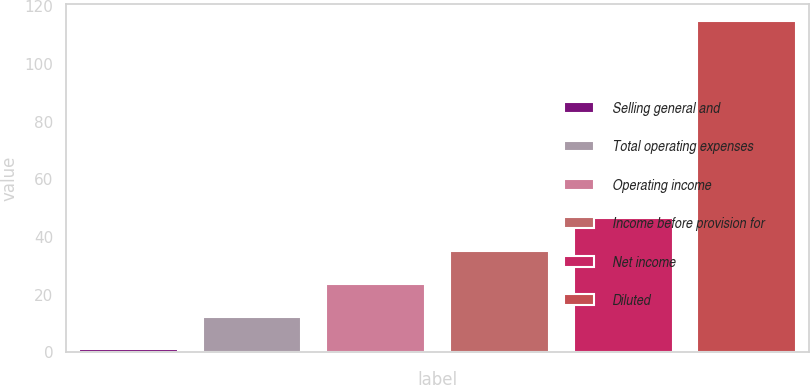Convert chart. <chart><loc_0><loc_0><loc_500><loc_500><bar_chart><fcel>Selling general and<fcel>Total operating expenses<fcel>Operating income<fcel>Income before provision for<fcel>Net income<fcel>Diluted<nl><fcel>1<fcel>12.4<fcel>23.8<fcel>35.2<fcel>46.6<fcel>115<nl></chart> 